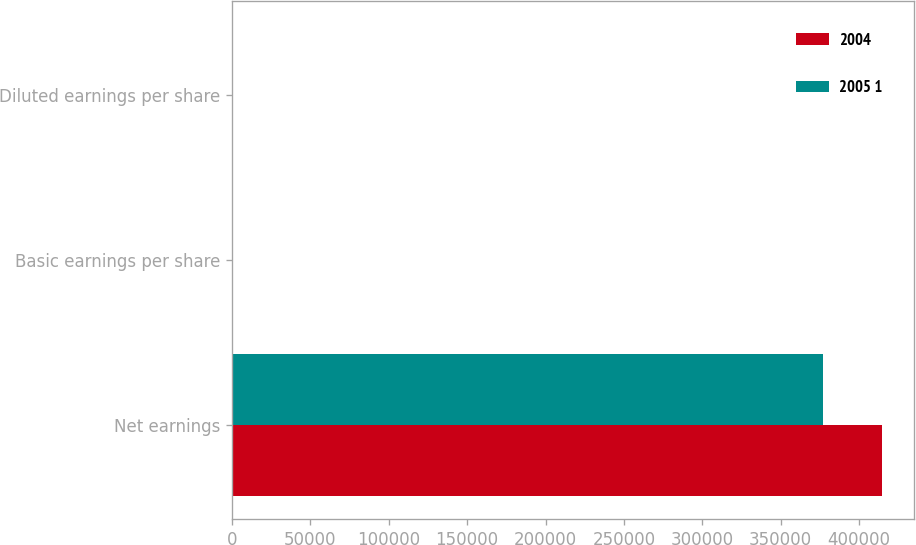Convert chart to OTSL. <chart><loc_0><loc_0><loc_500><loc_500><stacked_bar_chart><ecel><fcel>Net earnings<fcel>Basic earnings per share<fcel>Diluted earnings per share<nl><fcel>2004<fcel>414421<fcel>6.19<fcel>6.13<nl><fcel>2005 1<fcel>376930<fcel>5.65<fcel>5.58<nl></chart> 